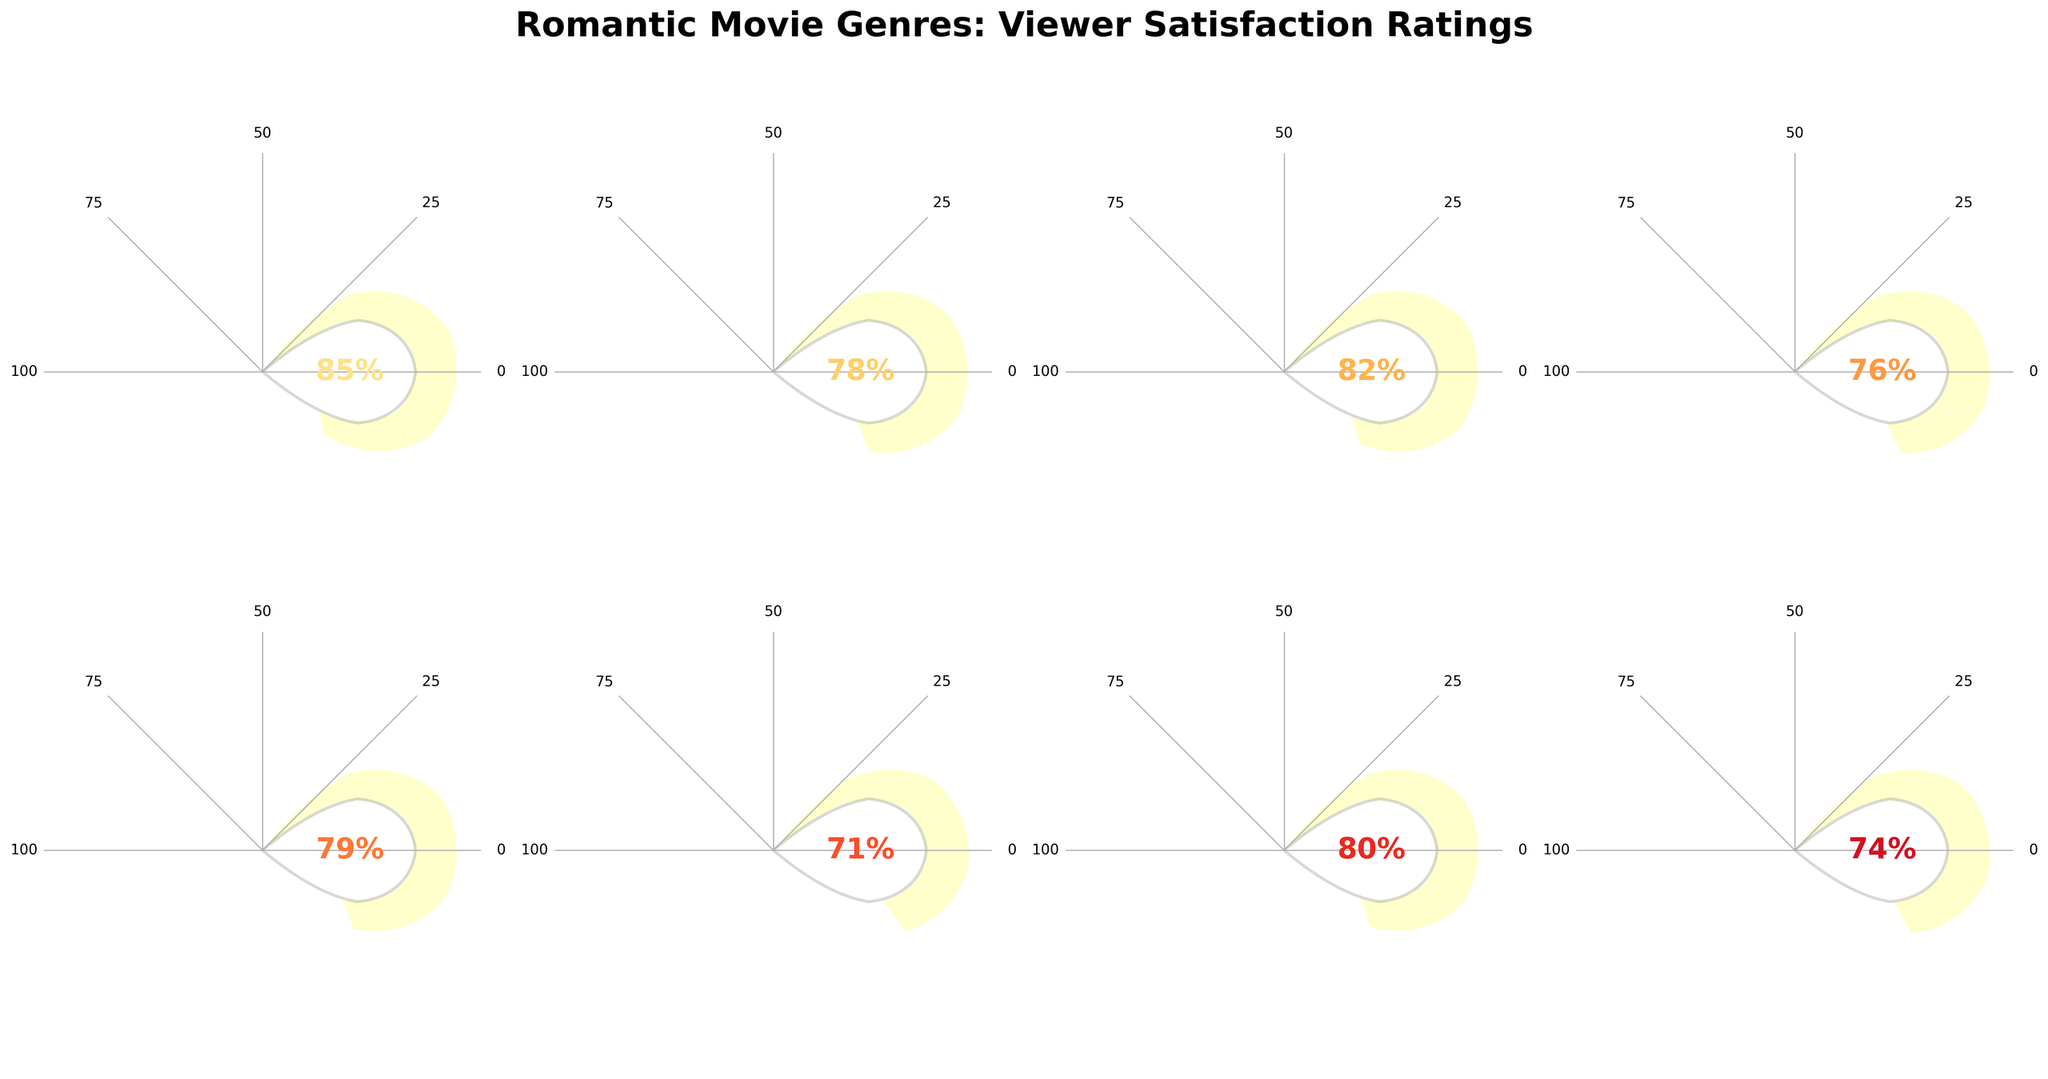How many romantic genres are shown in the figure? Count the number of gauge charts displayed in the figure. There are 8 genres: Romantic Comedy, Period Romance, Contemporary Romance, Romantic Drama, Romantic Fantasy, Romantic Thriller, Holiday Romance, and Young Adult Romance.
Answer: 8 Which genre has the highest viewer satisfaction rating? Look at each gauge chart and find the one with the highest percentage. The highest rating is 85%, which corresponds to Romantic Comedy.
Answer: Romantic Comedy What is the average viewer satisfaction rating for all the romantic genres shown? Add all the ratings (85 + 78 + 82 + 76 + 79 + 71 + 80 + 74 = 625) and divide by the number of genres (8). The average is 625 / 8 = 78.125%.
Answer: 78.125% Which genre has the lowest satisfaction rating, and what is its rating? Look at each gauge chart and find the one with the lowest percentage. The lowest rating is 71%, which corresponds to Romantic Thriller.
Answer: Romantic Thriller, 71% How much higher is the rating for Romantic Comedy compared to Romantic Thriller? Subtract the rating of Romantic Thriller (71%) from the rating of Romantic Comedy (85%). 85% - 71% = 14%.
Answer: 14% Which genres have a satisfaction rating above 80%? Look at the ratings and identify the ones higher than 80%. The genres are Romantic Comedy (85%), Contemporary Romance (82%), and Holiday Romance (80%).
Answer: Romantic Comedy, Contemporary Romance, Holiday Romance Between Period Romance and Romantic Fantasy, which genre has a higher rating and by how much? Compare the ratings: Period Romance (78%) and Romantic Fantasy (79%). Subtract the smaller rating from the larger. 79% - 78% = 1%. Romantic Fantasy is higher by 1%.
Answer: Romantic Fantasy, 1% What is the median satisfaction rating for the genres displayed? Arrange the ratings in increasing order: 71, 74, 76, 78, 79, 80, 82, 85. The median is the average of the 4th and 5th ratings: (78 + 79) / 2 = 78.5.
Answer: 78.5 Which genre's rating is closest to the overall average viewer satisfaction rating? The overall average is 78.125%. Compare this with each genre's rating. The closest is Period Romance with a rating of 78%.
Answer: Period Romance 